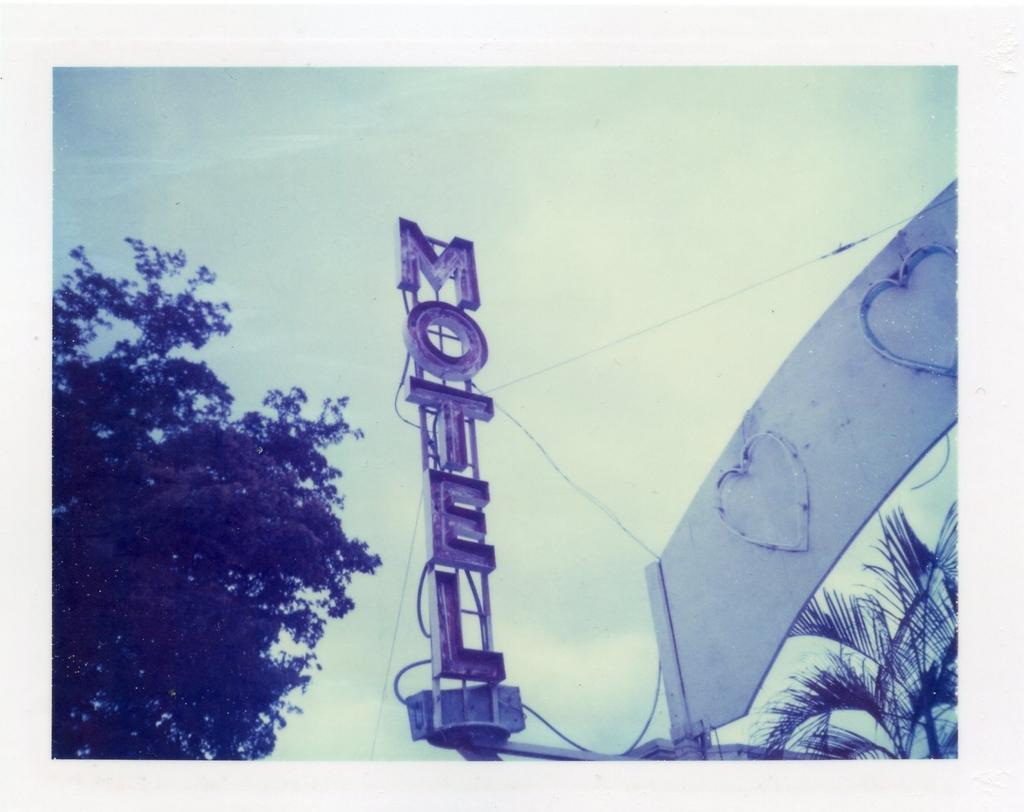Could you give a brief overview of what you see in this image? On the right side there is an arch and trees. Also there is a name board. On the left side there is a tree. In the background there is sky. 